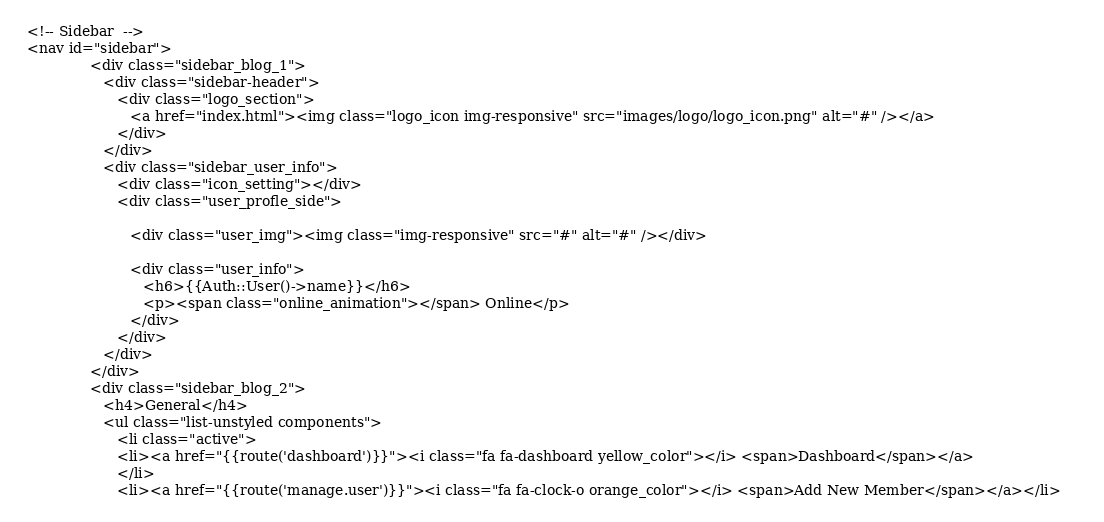<code> <loc_0><loc_0><loc_500><loc_500><_PHP_> <!-- Sidebar  -->
 <nav id="sidebar">
               <div class="sidebar_blog_1">
                  <div class="sidebar-header">
                     <div class="logo_section">
                        <a href="index.html"><img class="logo_icon img-responsive" src="images/logo/logo_icon.png" alt="#" /></a>
                     </div>
                  </div>
                  <div class="sidebar_user_info">
                     <div class="icon_setting"></div>                    
                     <div class="user_profle_side"> 
                   
                        <div class="user_img"><img class="img-responsive" src="#" alt="#" /></div>
                     
                        <div class="user_info">
                           <h6>{{Auth::User()->name}}</h6>
                           <p><span class="online_animation"></span> Online</p>
                        </div>
                     </div>
                  </div>
               </div>
               <div class="sidebar_blog_2">
                  <h4>General</h4>
                  <ul class="list-unstyled components">
                     <li class="active">
                     <li><a href="{{route('dashboard')}}"><i class="fa fa-dashboard yellow_color"></i> <span>Dashboard</span></a>                        
                     </li>
                     <li><a href="{{route('manage.user')}}"><i class="fa fa-clock-o orange_color"></i> <span>Add New Member</span></a></li></code> 